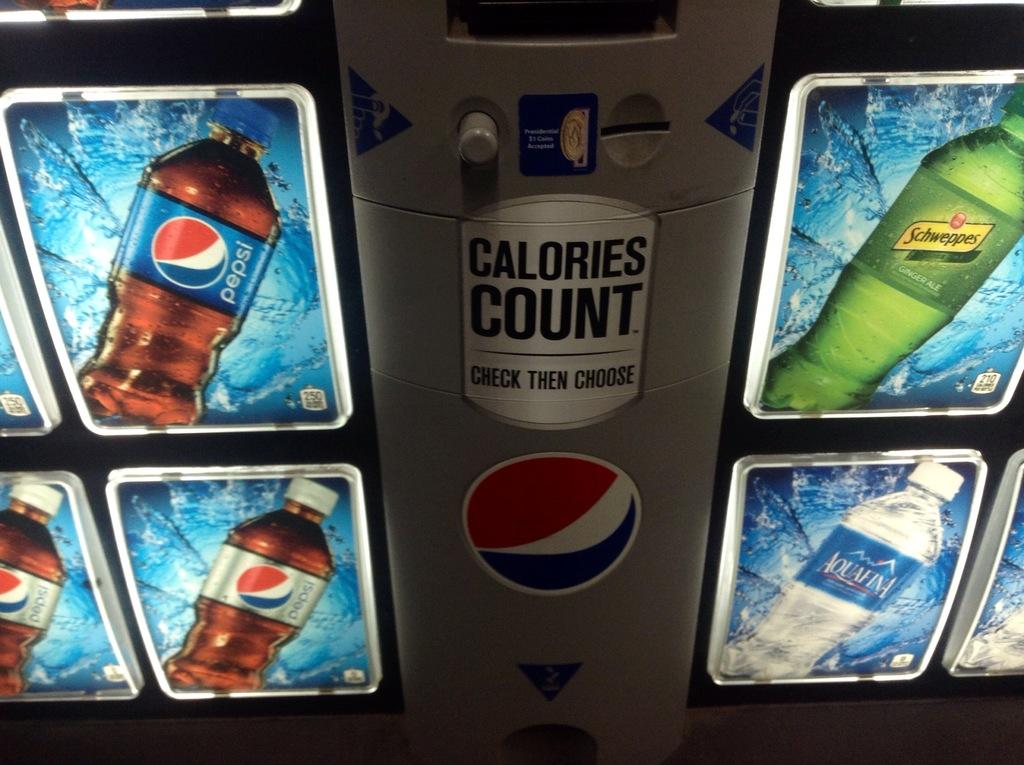What is counted?
Ensure brevity in your answer.  Calories. 